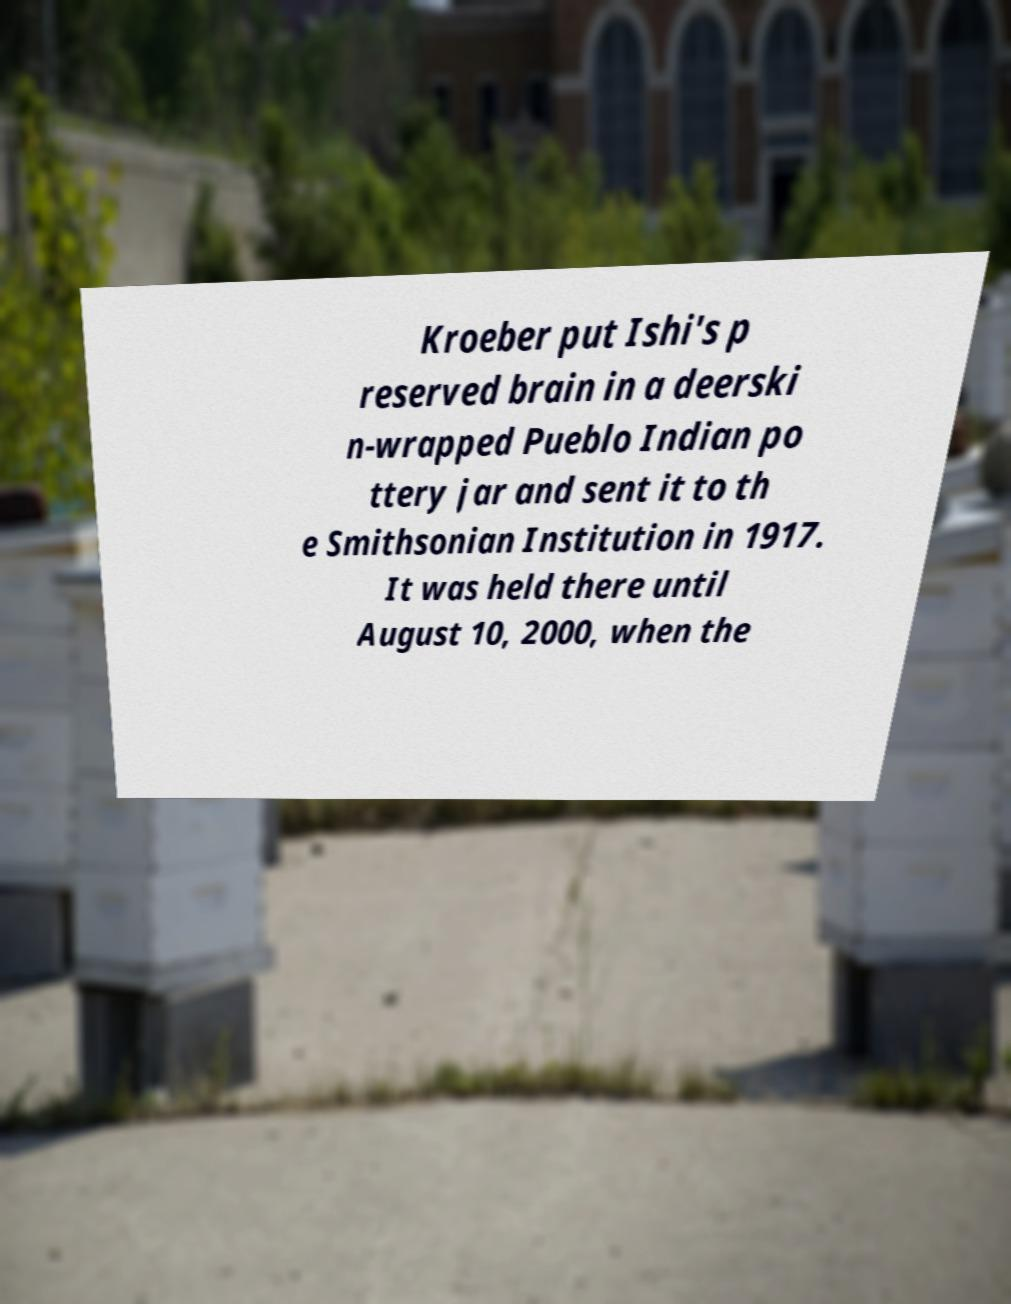I need the written content from this picture converted into text. Can you do that? Kroeber put Ishi's p reserved brain in a deerski n-wrapped Pueblo Indian po ttery jar and sent it to th e Smithsonian Institution in 1917. It was held there until August 10, 2000, when the 